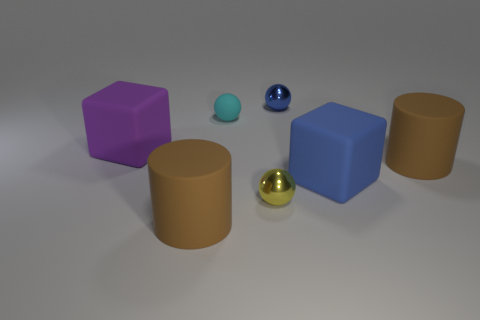Add 1 tiny blue metallic things. How many objects exist? 8 Subtract all cylinders. How many objects are left? 5 Add 6 large purple rubber blocks. How many large purple rubber blocks exist? 7 Subtract 0 brown spheres. How many objects are left? 7 Subtract all purple matte blocks. Subtract all tiny cyan spheres. How many objects are left? 5 Add 3 large blue matte cubes. How many large blue matte cubes are left? 4 